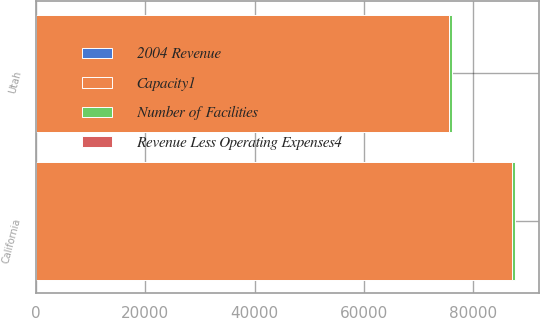Convert chart to OTSL. <chart><loc_0><loc_0><loc_500><loc_500><stacked_bar_chart><ecel><fcel>California<fcel>Utah<nl><fcel>2004 Revenue<fcel>3<fcel>8<nl><fcel>Number of Facilities<fcel>421<fcel>510<nl><fcel>Capacity1<fcel>87148<fcel>75537<nl><fcel>Revenue Less Operating Expenses4<fcel>100<fcel>100<nl></chart> 